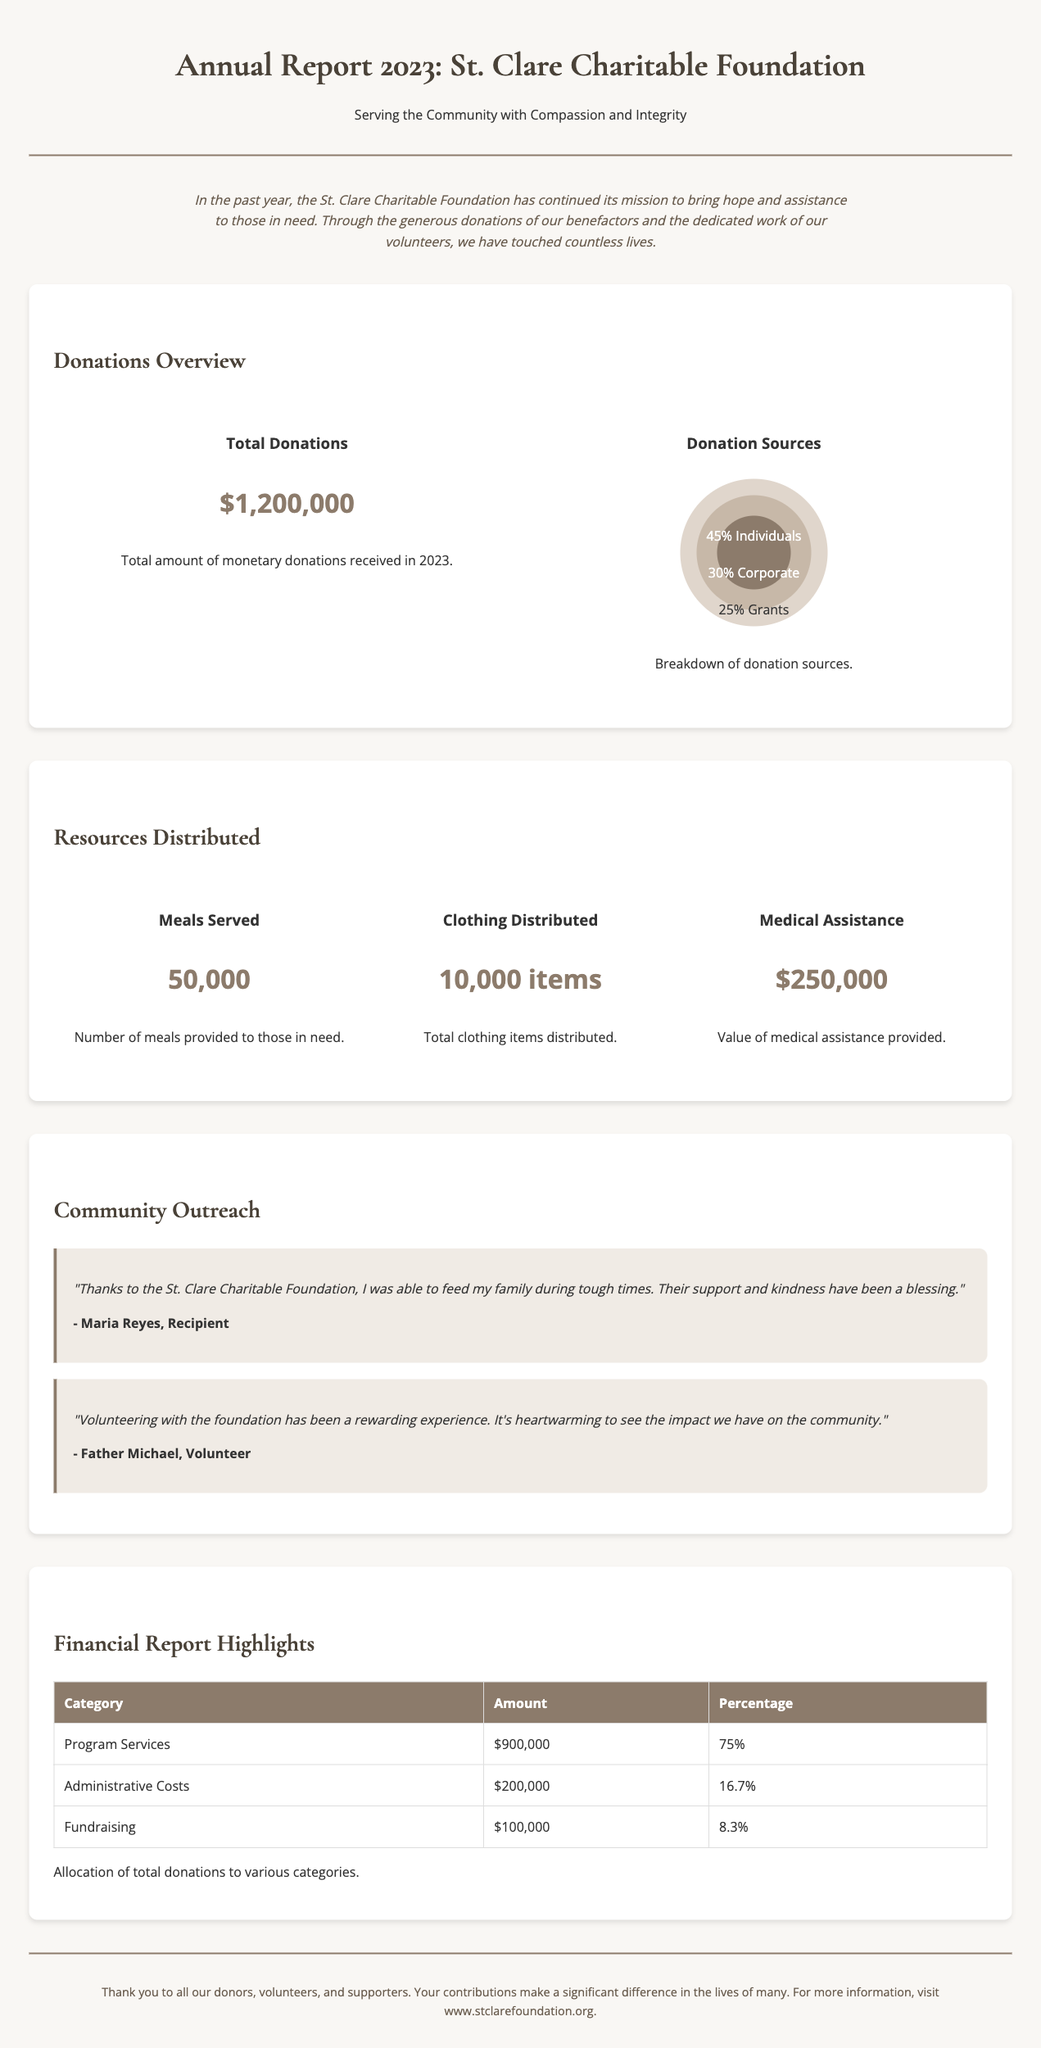What is the total amount of monetary donations received in 2023? The total donations amount is highlighted in the 'Donations Overview' section of the document.
Answer: $1,200,000 What percentage of donations come from individuals? The donation sources breakdown illustrates the percentages of each category.
Answer: 45% How many meals were served? The number of meals provided is noted in the 'Resources Distributed' section of the report.
Answer: 50,000 What is the value of medical assistance provided? The value of medical assistance is specifically mentioned in the data presented in the document.
Answer: $250,000 Who is a recipient that provided a testimonial? The testimonial section features personal accounts from recipients, allowing the identification of specific individuals.
Answer: Maria Reyes What is the percentage of funds allocated to program services? The financial report lists expenditure categories along with their respective percentages.
Answer: 75% What was the amount spent on administrative costs? Administrative costs are detailed within the financial report, which provides specific figures for each category.
Answer: $200,000 What has been emphasized about the contributions of donors? The footer expresses gratitude to the donors and highlights their essential role in the foundation’s work.
Answer: Significant difference What type of data is presented in the 'Community Outreach' section? This section contains personal testimonials that reflect the impact of the foundation's services on individuals and volunteers.
Answer: Testimonials 